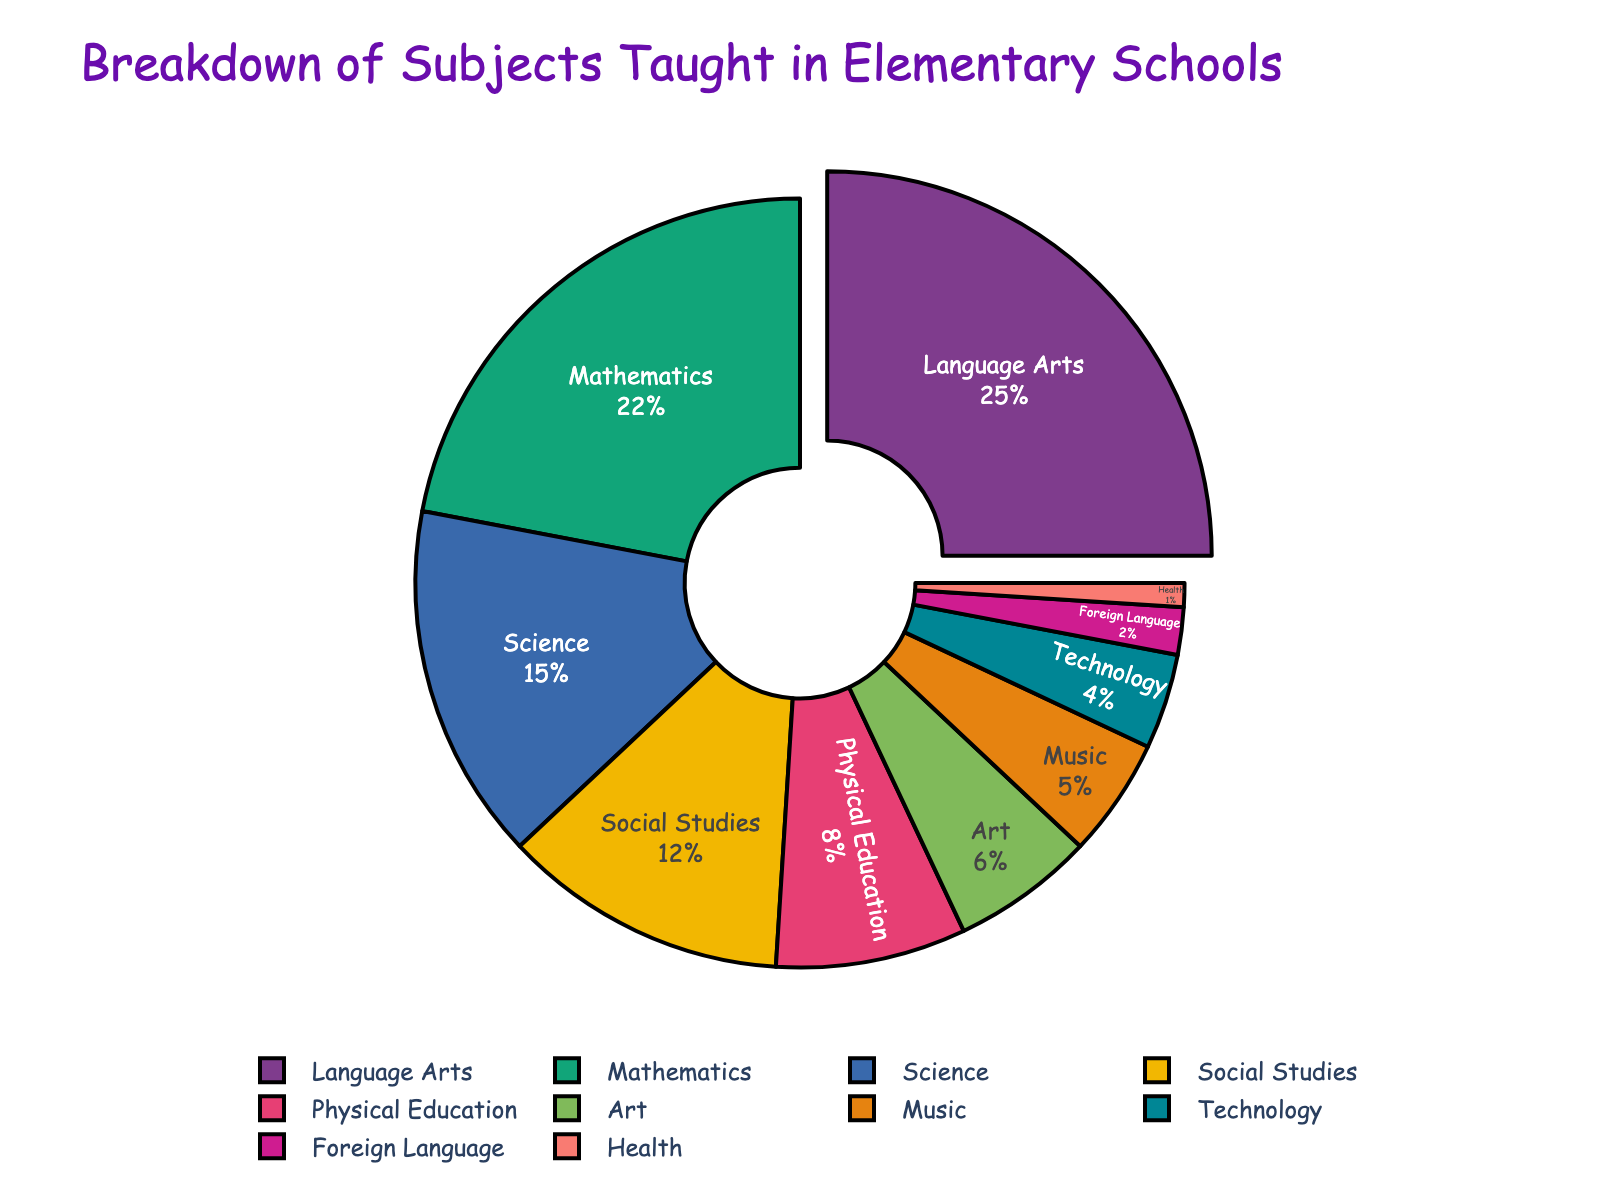What percentage of the total subjects taught is accounted for by Mathematics and Science combined? Add the percentage of Mathematics (22%) and Science (15%) to get the combined total. 22% + 15% = 37%
Answer: 37% Which two subjects have the smallest percentages? Identify the two smallest values in the list of percentages, which are Foreign Language (2%) and Health (1%)
Answer: Foreign Language and Health Which subject occupies the largest portion of the pie chart? Look at the segment that occupies the largest area of the pie chart, which is Language Arts at 25%
Answer: Language Arts By how much does the percentage of Music exceed the percentage of Health? Subtract the Health percentage (1%) from the Music percentage (5%). 5% - 1% = 4%
Answer: 4% What is the average percentage of all subjects taught? Sum all percentages and divide by the number of subjects: (22 + 25 + 15 + 12 + 8 + 6 + 5 + 4 + 2 + 1) / 10 = 100 / 10 = 10
Answer: 10% How much larger is Social Studies compared to Physical Education? Subtract the percentage of Physical Education (8%) from that of Social Studies (12%). 12% - 8% = 4%
Answer: 4% What proportion of the pie chart is taken up by the core academic subjects (Mathematics, Language Arts, Science, and Social Studies)? Sum the percentages of the core subjects: 22 + 25 + 15 + 12 = 74%
Answer: 74% Which subject is visually differentiated by being pulled slightly apart in the chart? Observe which segment is visually separated. This is typically done for the largest segment, which in this case is Language Arts
Answer: Language Arts If Technology and Art were combined into a single category, what percentage would they represent together? Sum the percentages for Technology (4%) and Art (6%) to get their combined value. 4% + 6% = 10%
Answer: 10% Compare the combined percentage of Physical Education, Art, and Music to the percentage of Language Arts. Is it higher or lower? Sum the percentages of Physical Education (8%), Art (6%), and Music (5%), then compare to Language Arts (25%): 8 + 6 + 5 = 19%, which is less than 25%
Answer: Lower 